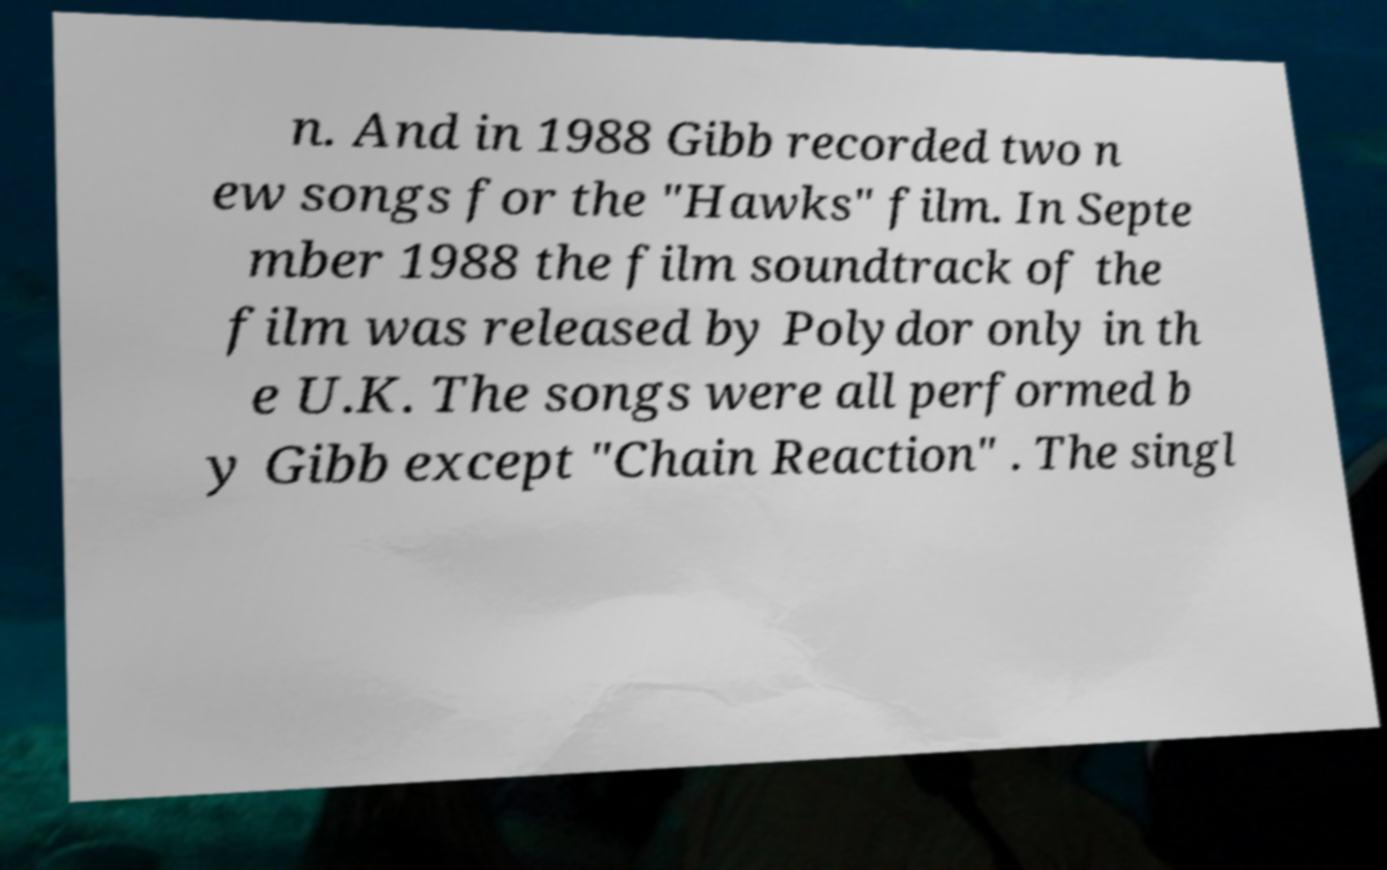Please identify and transcribe the text found in this image. n. And in 1988 Gibb recorded two n ew songs for the "Hawks" film. In Septe mber 1988 the film soundtrack of the film was released by Polydor only in th e U.K. The songs were all performed b y Gibb except "Chain Reaction" . The singl 